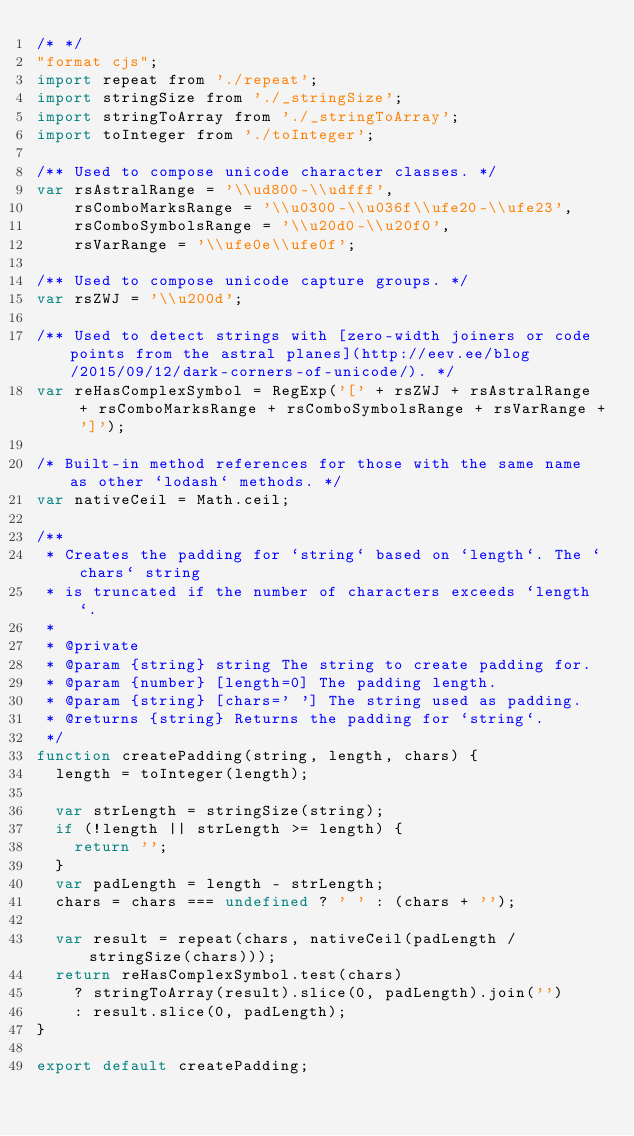<code> <loc_0><loc_0><loc_500><loc_500><_JavaScript_>/* */ 
"format cjs";
import repeat from './repeat';
import stringSize from './_stringSize';
import stringToArray from './_stringToArray';
import toInteger from './toInteger';

/** Used to compose unicode character classes. */
var rsAstralRange = '\\ud800-\\udfff',
    rsComboMarksRange = '\\u0300-\\u036f\\ufe20-\\ufe23',
    rsComboSymbolsRange = '\\u20d0-\\u20f0',
    rsVarRange = '\\ufe0e\\ufe0f';

/** Used to compose unicode capture groups. */
var rsZWJ = '\\u200d';

/** Used to detect strings with [zero-width joiners or code points from the astral planes](http://eev.ee/blog/2015/09/12/dark-corners-of-unicode/). */
var reHasComplexSymbol = RegExp('[' + rsZWJ + rsAstralRange  + rsComboMarksRange + rsComboSymbolsRange + rsVarRange + ']');

/* Built-in method references for those with the same name as other `lodash` methods. */
var nativeCeil = Math.ceil;

/**
 * Creates the padding for `string` based on `length`. The `chars` string
 * is truncated if the number of characters exceeds `length`.
 *
 * @private
 * @param {string} string The string to create padding for.
 * @param {number} [length=0] The padding length.
 * @param {string} [chars=' '] The string used as padding.
 * @returns {string} Returns the padding for `string`.
 */
function createPadding(string, length, chars) {
  length = toInteger(length);

  var strLength = stringSize(string);
  if (!length || strLength >= length) {
    return '';
  }
  var padLength = length - strLength;
  chars = chars === undefined ? ' ' : (chars + '');

  var result = repeat(chars, nativeCeil(padLength / stringSize(chars)));
  return reHasComplexSymbol.test(chars)
    ? stringToArray(result).slice(0, padLength).join('')
    : result.slice(0, padLength);
}

export default createPadding;
</code> 